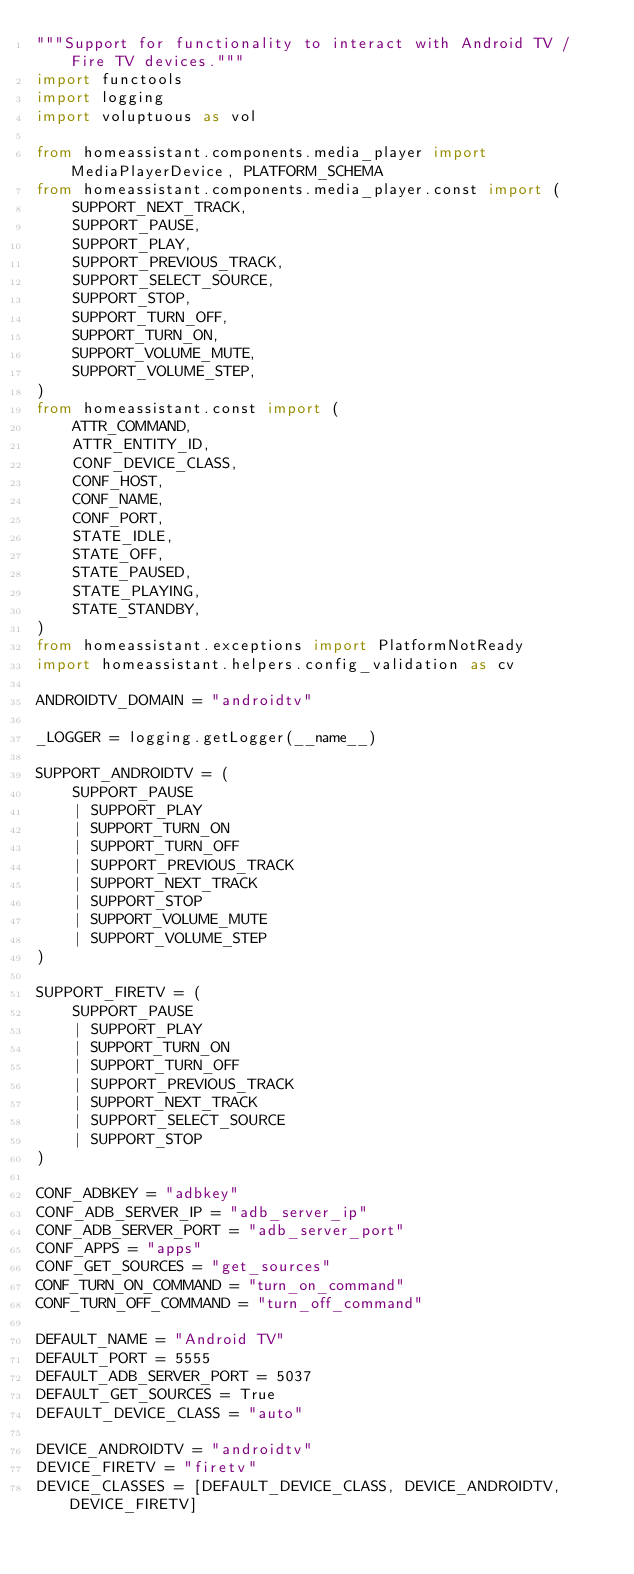<code> <loc_0><loc_0><loc_500><loc_500><_Python_>"""Support for functionality to interact with Android TV / Fire TV devices."""
import functools
import logging
import voluptuous as vol

from homeassistant.components.media_player import MediaPlayerDevice, PLATFORM_SCHEMA
from homeassistant.components.media_player.const import (
    SUPPORT_NEXT_TRACK,
    SUPPORT_PAUSE,
    SUPPORT_PLAY,
    SUPPORT_PREVIOUS_TRACK,
    SUPPORT_SELECT_SOURCE,
    SUPPORT_STOP,
    SUPPORT_TURN_OFF,
    SUPPORT_TURN_ON,
    SUPPORT_VOLUME_MUTE,
    SUPPORT_VOLUME_STEP,
)
from homeassistant.const import (
    ATTR_COMMAND,
    ATTR_ENTITY_ID,
    CONF_DEVICE_CLASS,
    CONF_HOST,
    CONF_NAME,
    CONF_PORT,
    STATE_IDLE,
    STATE_OFF,
    STATE_PAUSED,
    STATE_PLAYING,
    STATE_STANDBY,
)
from homeassistant.exceptions import PlatformNotReady
import homeassistant.helpers.config_validation as cv

ANDROIDTV_DOMAIN = "androidtv"

_LOGGER = logging.getLogger(__name__)

SUPPORT_ANDROIDTV = (
    SUPPORT_PAUSE
    | SUPPORT_PLAY
    | SUPPORT_TURN_ON
    | SUPPORT_TURN_OFF
    | SUPPORT_PREVIOUS_TRACK
    | SUPPORT_NEXT_TRACK
    | SUPPORT_STOP
    | SUPPORT_VOLUME_MUTE
    | SUPPORT_VOLUME_STEP
)

SUPPORT_FIRETV = (
    SUPPORT_PAUSE
    | SUPPORT_PLAY
    | SUPPORT_TURN_ON
    | SUPPORT_TURN_OFF
    | SUPPORT_PREVIOUS_TRACK
    | SUPPORT_NEXT_TRACK
    | SUPPORT_SELECT_SOURCE
    | SUPPORT_STOP
)

CONF_ADBKEY = "adbkey"
CONF_ADB_SERVER_IP = "adb_server_ip"
CONF_ADB_SERVER_PORT = "adb_server_port"
CONF_APPS = "apps"
CONF_GET_SOURCES = "get_sources"
CONF_TURN_ON_COMMAND = "turn_on_command"
CONF_TURN_OFF_COMMAND = "turn_off_command"

DEFAULT_NAME = "Android TV"
DEFAULT_PORT = 5555
DEFAULT_ADB_SERVER_PORT = 5037
DEFAULT_GET_SOURCES = True
DEFAULT_DEVICE_CLASS = "auto"

DEVICE_ANDROIDTV = "androidtv"
DEVICE_FIRETV = "firetv"
DEVICE_CLASSES = [DEFAULT_DEVICE_CLASS, DEVICE_ANDROIDTV, DEVICE_FIRETV]
</code> 